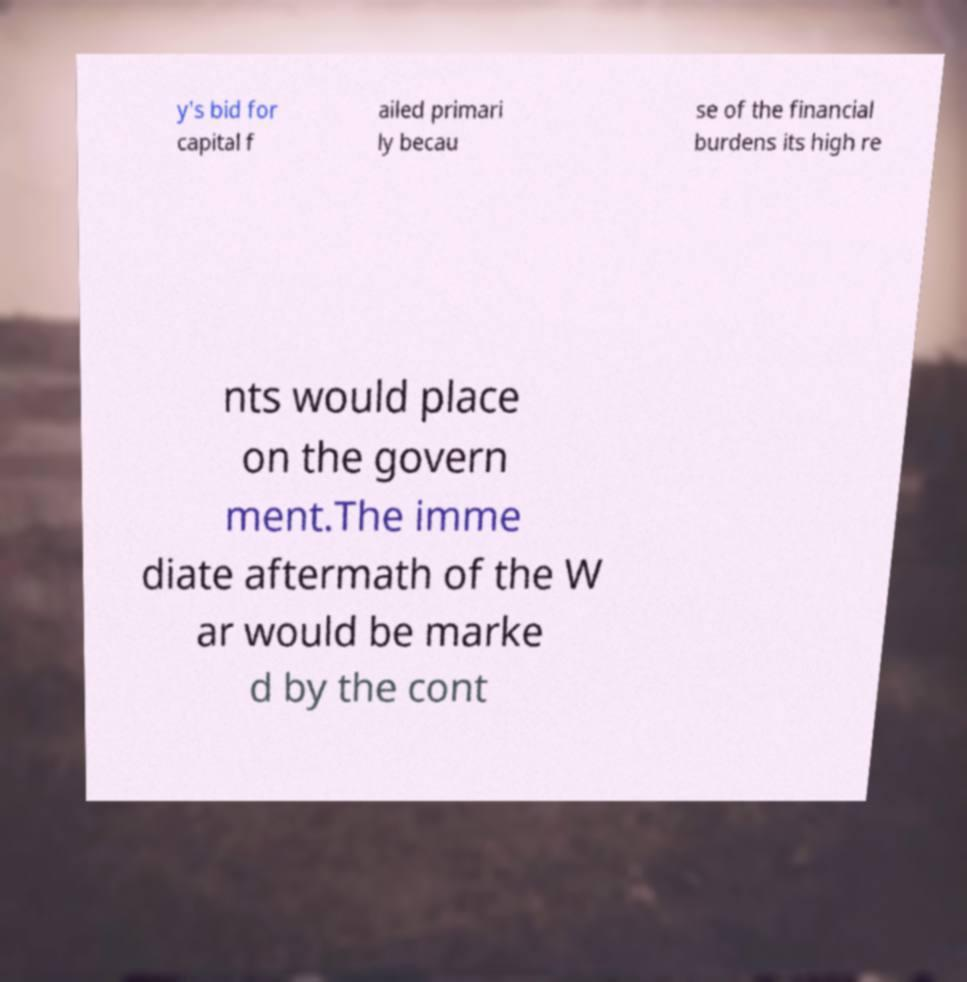Can you accurately transcribe the text from the provided image for me? y's bid for capital f ailed primari ly becau se of the financial burdens its high re nts would place on the govern ment.The imme diate aftermath of the W ar would be marke d by the cont 